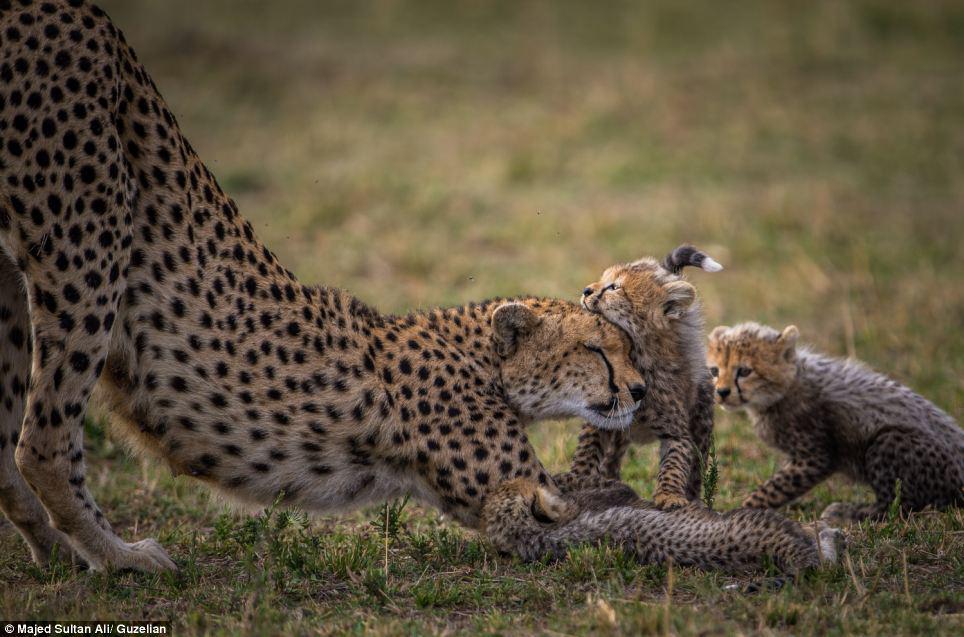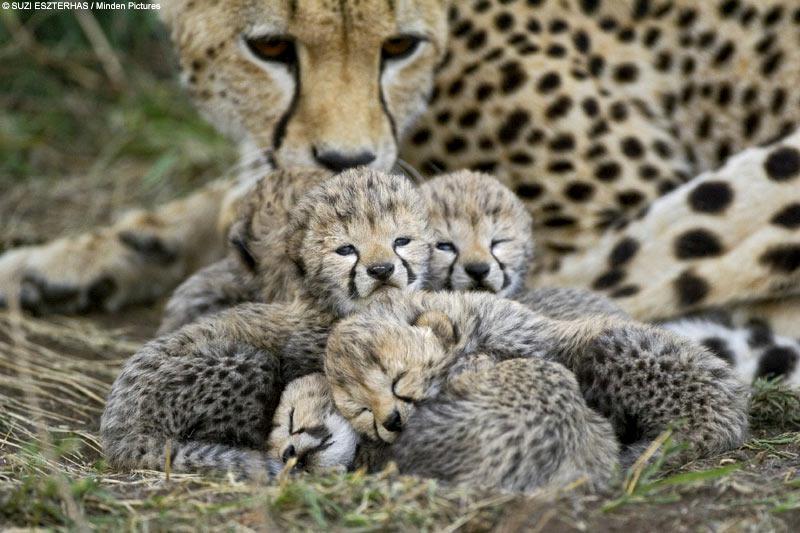The first image is the image on the left, the second image is the image on the right. Analyze the images presented: Is the assertion "There are 4 cheetas in the field." valid? Answer yes or no. No. The first image is the image on the left, the second image is the image on the right. Given the left and right images, does the statement "Each image shows exactly two cheetahs." hold true? Answer yes or no. No. 